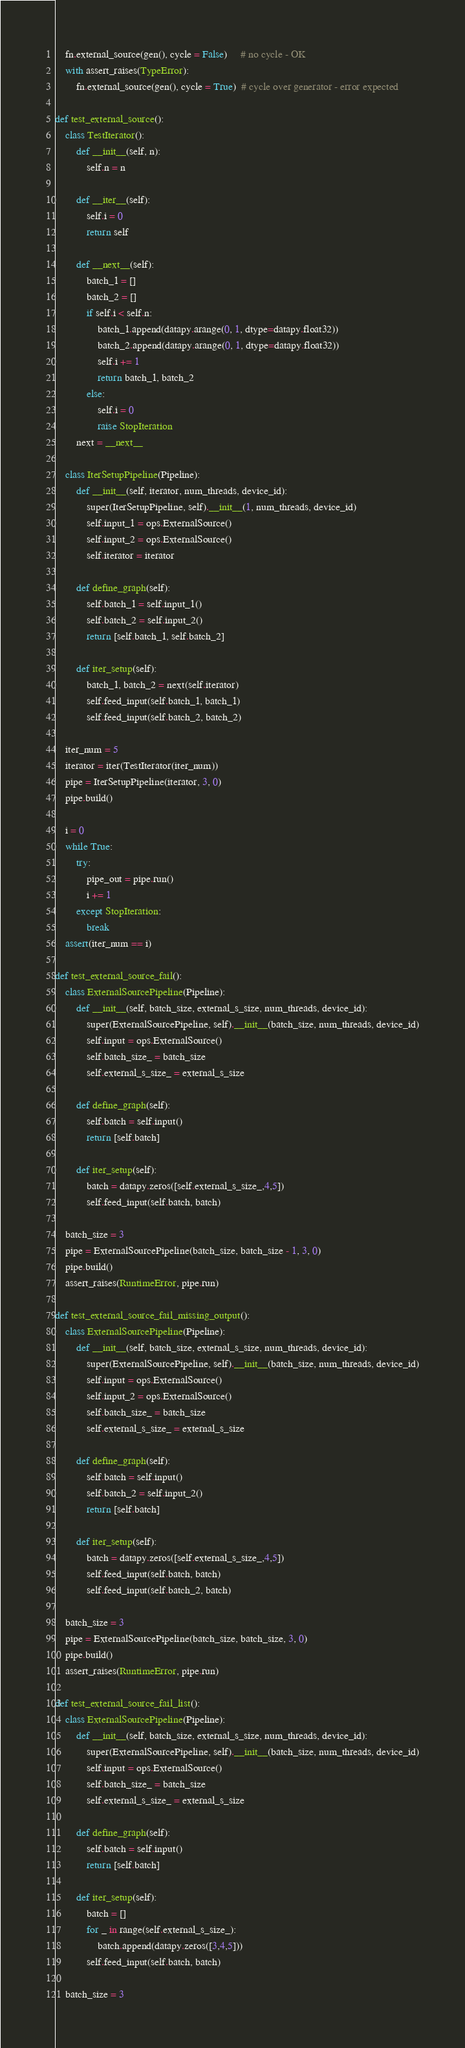<code> <loc_0><loc_0><loc_500><loc_500><_Python_>
    fn.external_source(gen(), cycle = False)     # no cycle - OK
    with assert_raises(TypeError):
        fn.external_source(gen(), cycle = True)  # cycle over generator - error expected

def test_external_source():
    class TestIterator():
        def __init__(self, n):
            self.n = n

        def __iter__(self):
            self.i = 0
            return self

        def __next__(self):
            batch_1 = []
            batch_2 = []
            if self.i < self.n:
                batch_1.append(datapy.arange(0, 1, dtype=datapy.float32))
                batch_2.append(datapy.arange(0, 1, dtype=datapy.float32))
                self.i += 1
                return batch_1, batch_2
            else:
                self.i = 0
                raise StopIteration
        next = __next__

    class IterSetupPipeline(Pipeline):
        def __init__(self, iterator, num_threads, device_id):
            super(IterSetupPipeline, self).__init__(1, num_threads, device_id)
            self.input_1 = ops.ExternalSource()
            self.input_2 = ops.ExternalSource()
            self.iterator = iterator

        def define_graph(self):
            self.batch_1 = self.input_1()
            self.batch_2 = self.input_2()
            return [self.batch_1, self.batch_2]

        def iter_setup(self):
            batch_1, batch_2 = next(self.iterator)
            self.feed_input(self.batch_1, batch_1)
            self.feed_input(self.batch_2, batch_2)

    iter_num = 5
    iterator = iter(TestIterator(iter_num))
    pipe = IterSetupPipeline(iterator, 3, 0)
    pipe.build()

    i = 0
    while True:
        try:
            pipe_out = pipe.run()
            i += 1
        except StopIteration:
            break
    assert(iter_num == i)

def test_external_source_fail():
    class ExternalSourcePipeline(Pipeline):
        def __init__(self, batch_size, external_s_size, num_threads, device_id):
            super(ExternalSourcePipeline, self).__init__(batch_size, num_threads, device_id)
            self.input = ops.ExternalSource()
            self.batch_size_ = batch_size
            self.external_s_size_ = external_s_size

        def define_graph(self):
            self.batch = self.input()
            return [self.batch]

        def iter_setup(self):
            batch = datapy.zeros([self.external_s_size_,4,5])
            self.feed_input(self.batch, batch)

    batch_size = 3
    pipe = ExternalSourcePipeline(batch_size, batch_size - 1, 3, 0)
    pipe.build()
    assert_raises(RuntimeError, pipe.run)

def test_external_source_fail_missing_output():
    class ExternalSourcePipeline(Pipeline):
        def __init__(self, batch_size, external_s_size, num_threads, device_id):
            super(ExternalSourcePipeline, self).__init__(batch_size, num_threads, device_id)
            self.input = ops.ExternalSource()
            self.input_2 = ops.ExternalSource()
            self.batch_size_ = batch_size
            self.external_s_size_ = external_s_size

        def define_graph(self):
            self.batch = self.input()
            self.batch_2 = self.input_2()
            return [self.batch]

        def iter_setup(self):
            batch = datapy.zeros([self.external_s_size_,4,5])
            self.feed_input(self.batch, batch)
            self.feed_input(self.batch_2, batch)

    batch_size = 3
    pipe = ExternalSourcePipeline(batch_size, batch_size, 3, 0)
    pipe.build()
    assert_raises(RuntimeError, pipe.run)

def test_external_source_fail_list():
    class ExternalSourcePipeline(Pipeline):
        def __init__(self, batch_size, external_s_size, num_threads, device_id):
            super(ExternalSourcePipeline, self).__init__(batch_size, num_threads, device_id)
            self.input = ops.ExternalSource()
            self.batch_size_ = batch_size
            self.external_s_size_ = external_s_size

        def define_graph(self):
            self.batch = self.input()
            return [self.batch]

        def iter_setup(self):
            batch = []
            for _ in range(self.external_s_size_):
                batch.append(datapy.zeros([3,4,5]))
            self.feed_input(self.batch, batch)

    batch_size = 3</code> 